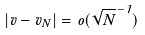<formula> <loc_0><loc_0><loc_500><loc_500>| v - v _ { N } | = o ( \sqrt { N } ^ { - 1 } )</formula> 